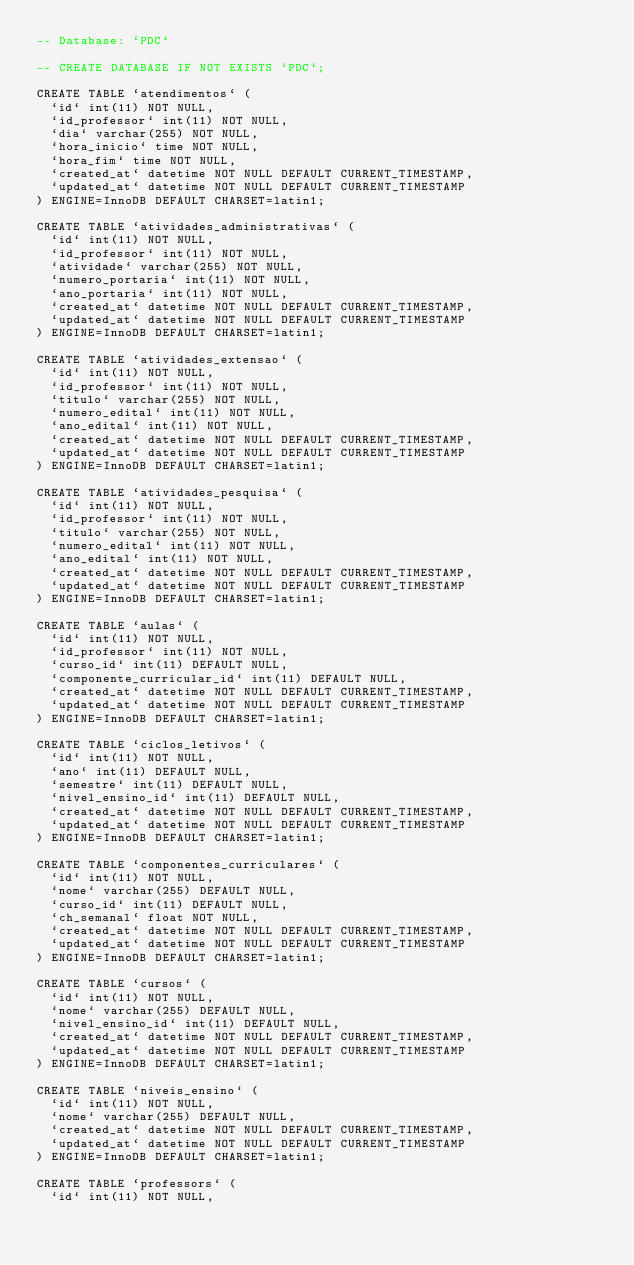<code> <loc_0><loc_0><loc_500><loc_500><_SQL_>-- Database: `PDC`

-- CREATE DATABASE IF NOT EXISTS `PDC`;

CREATE TABLE `atendimentos` (
  `id` int(11) NOT NULL,
  `id_professor` int(11) NOT NULL,
  `dia` varchar(255) NOT NULL,
  `hora_inicio` time NOT NULL,
  `hora_fim` time NOT NULL,
  `created_at` datetime NOT NULL DEFAULT CURRENT_TIMESTAMP,
  `updated_at` datetime NOT NULL DEFAULT CURRENT_TIMESTAMP
) ENGINE=InnoDB DEFAULT CHARSET=latin1;

CREATE TABLE `atividades_administrativas` (
  `id` int(11) NOT NULL,
  `id_professor` int(11) NOT NULL,
  `atividade` varchar(255) NOT NULL,
  `numero_portaria` int(11) NOT NULL,
  `ano_portaria` int(11) NOT NULL,
  `created_at` datetime NOT NULL DEFAULT CURRENT_TIMESTAMP,
  `updated_at` datetime NOT NULL DEFAULT CURRENT_TIMESTAMP
) ENGINE=InnoDB DEFAULT CHARSET=latin1;

CREATE TABLE `atividades_extensao` (
  `id` int(11) NOT NULL,
  `id_professor` int(11) NOT NULL,
  `titulo` varchar(255) NOT NULL,
  `numero_edital` int(11) NOT NULL,
  `ano_edital` int(11) NOT NULL,
  `created_at` datetime NOT NULL DEFAULT CURRENT_TIMESTAMP,
  `updated_at` datetime NOT NULL DEFAULT CURRENT_TIMESTAMP
) ENGINE=InnoDB DEFAULT CHARSET=latin1;

CREATE TABLE `atividades_pesquisa` (
  `id` int(11) NOT NULL,
  `id_professor` int(11) NOT NULL,
  `titulo` varchar(255) NOT NULL,
  `numero_edital` int(11) NOT NULL,
  `ano_edital` int(11) NOT NULL,
  `created_at` datetime NOT NULL DEFAULT CURRENT_TIMESTAMP,
  `updated_at` datetime NOT NULL DEFAULT CURRENT_TIMESTAMP
) ENGINE=InnoDB DEFAULT CHARSET=latin1;

CREATE TABLE `aulas` (
  `id` int(11) NOT NULL,
  `id_professor` int(11) NOT NULL,
  `curso_id` int(11) DEFAULT NULL,
  `componente_curricular_id` int(11) DEFAULT NULL,
  `created_at` datetime NOT NULL DEFAULT CURRENT_TIMESTAMP,
  `updated_at` datetime NOT NULL DEFAULT CURRENT_TIMESTAMP
) ENGINE=InnoDB DEFAULT CHARSET=latin1;

CREATE TABLE `ciclos_letivos` (
  `id` int(11) NOT NULL,
  `ano` int(11) DEFAULT NULL,
  `semestre` int(11) DEFAULT NULL,
  `nivel_ensino_id` int(11) DEFAULT NULL,
  `created_at` datetime NOT NULL DEFAULT CURRENT_TIMESTAMP,
  `updated_at` datetime NOT NULL DEFAULT CURRENT_TIMESTAMP
) ENGINE=InnoDB DEFAULT CHARSET=latin1;

CREATE TABLE `componentes_curriculares` (
  `id` int(11) NOT NULL,
  `nome` varchar(255) DEFAULT NULL,
  `curso_id` int(11) DEFAULT NULL,
  `ch_semanal` float NOT NULL,
  `created_at` datetime NOT NULL DEFAULT CURRENT_TIMESTAMP,
  `updated_at` datetime NOT NULL DEFAULT CURRENT_TIMESTAMP
) ENGINE=InnoDB DEFAULT CHARSET=latin1;

CREATE TABLE `cursos` (
  `id` int(11) NOT NULL,
  `nome` varchar(255) DEFAULT NULL,
  `nivel_ensino_id` int(11) DEFAULT NULL,
  `created_at` datetime NOT NULL DEFAULT CURRENT_TIMESTAMP,
  `updated_at` datetime NOT NULL DEFAULT CURRENT_TIMESTAMP
) ENGINE=InnoDB DEFAULT CHARSET=latin1;

CREATE TABLE `niveis_ensino` (
  `id` int(11) NOT NULL,
  `nome` varchar(255) DEFAULT NULL,
  `created_at` datetime NOT NULL DEFAULT CURRENT_TIMESTAMP,
  `updated_at` datetime NOT NULL DEFAULT CURRENT_TIMESTAMP
) ENGINE=InnoDB DEFAULT CHARSET=latin1;

CREATE TABLE `professors` (
  `id` int(11) NOT NULL,</code> 